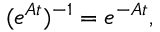<formula> <loc_0><loc_0><loc_500><loc_500>( e ^ { A t } ) ^ { - 1 } = e ^ { - A t } ,</formula> 